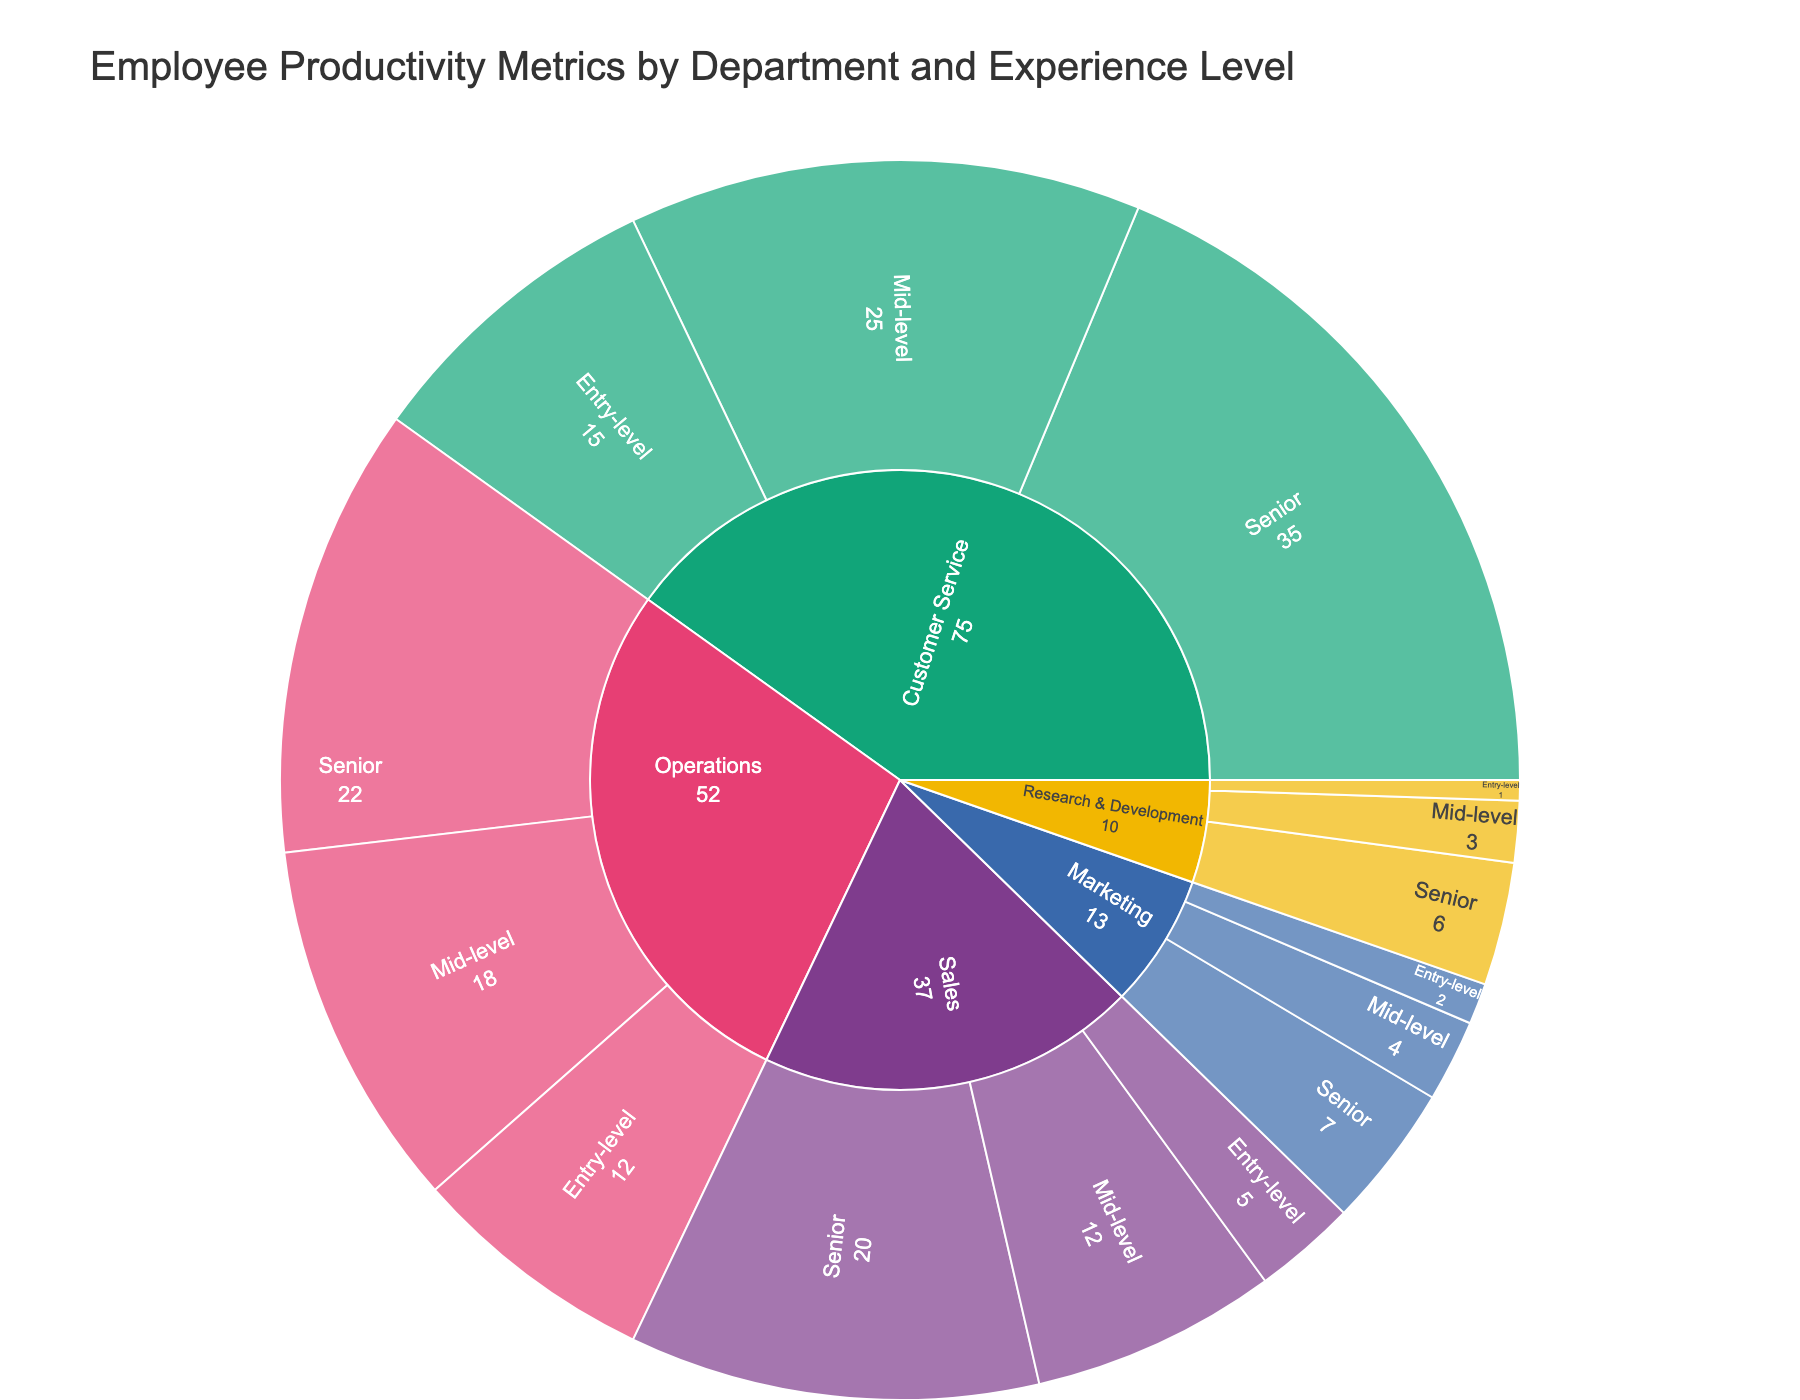What's the title of the figure? The title of the figure is displayed at the top center of the plot. It gives a clear description of what the figure represents.
Answer: "Employee Productivity Metrics by Department and Experience Level" Which department and experience level has the highest productivity metric in units produced per hour? By examining the segments related to "Units Produced Per Hour," and comparing the values, we see that Operations, Senior level has the highest productivity metric of 22 units produced per hour.
Answer: Operations, Senior level How many entry-level experience categories are represented in the plot? Each department has an entry-level category. By counting the unique segments labeled "Entry-level," we can find the total number. There are five departments, so there are five entry-level categories.
Answer: 5 What is the total value of units produced per hour for the operations department across all experience levels? The sum of Units Produced Per Hour for Operations can be calculated by adding the values for entry-level (12), mid-level (18), and senior (22). (12 + 18 + 22 = 52)
Answer: 52 Which experience level in the Customer Service department resolves the fewest tickets per day? By checking the values in the Customer Service department, we see that the entry-level experience resolves 15 tickets per day, which is fewer than mid-level or senior level.
Answer: Entry-level Compare the productivity metric for mid-level employees in Sales and Marketing in their respective metrics. Mid-level employees in Sales close 12 deals per month, whereas mid-level employees in Marketing launch 4 campaigns per quarter. Therefore, Sales has the higher productivity metric.
Answer: Sales Which department has the most significant increase in productivity metric from entry-level to senior level? By comparing the difference in productivity metrics between entry-level and senior levels for each department: Operations (22-12=10), Sales (20-5=15), Research & Development (6-1=5), Marketing (7-2=5), and Customer Service (35-15=20), Customer Service has the most significant increase.
Answer: Customer Service What is the average number of patents filed per year by Research & Development employees? The average can be calculated by summing the values and dividing by the number of experience levels. (1 + 3 + 6) / 3 = 3.33.
Answer: 3.33 Does the senior level in any department have a lower productivity metric than any mid-level in another department? If so, which? By comparing the senior levels to the mid-levels: The lowest senior level metric is in Research & Development (6), and the highest mid-level metric is in Customer Service (25). Since 6 < 25, this condition is true for Research & Development senior level compared to Customer Service mid-level.
Answer: Research & Development Which department's functional metrics do not overlap with any other department's metrics? By examining the specific productivity metrics for each department, we identify that Research & Development (Patents Filed Per Year) has unique metrics that do not overlap with other departments' productivity metrics.
Answer: Research & Development 